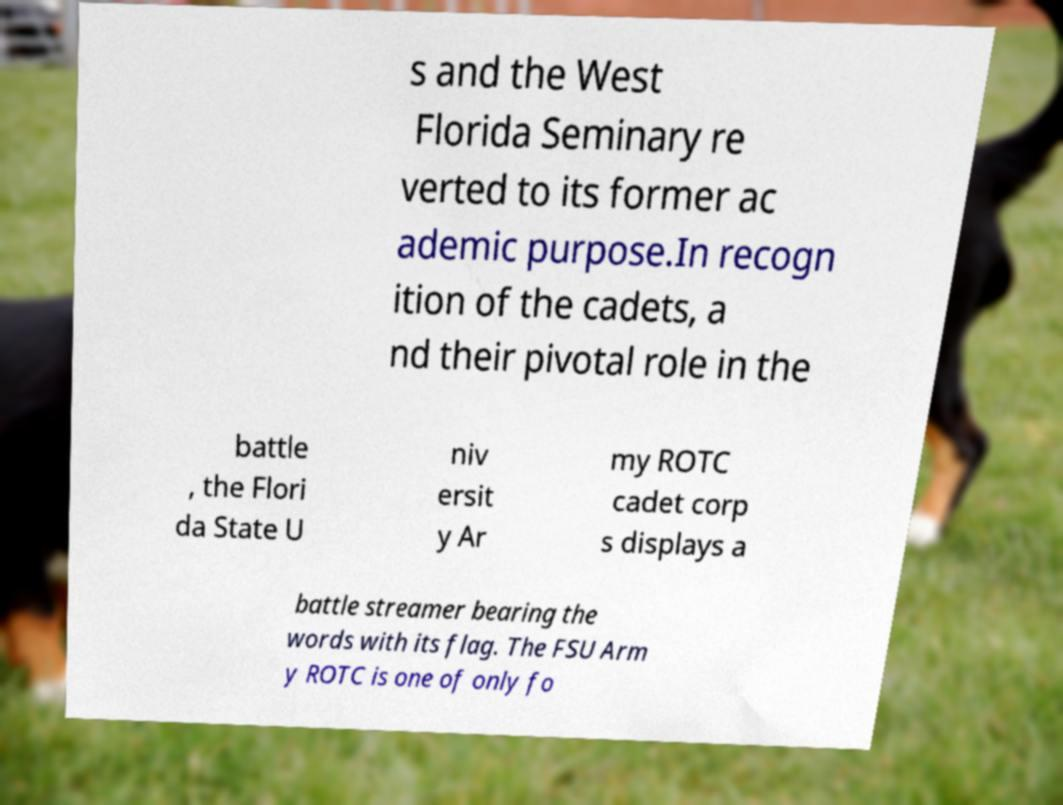Can you accurately transcribe the text from the provided image for me? s and the West Florida Seminary re verted to its former ac ademic purpose.In recogn ition of the cadets, a nd their pivotal role in the battle , the Flori da State U niv ersit y Ar my ROTC cadet corp s displays a battle streamer bearing the words with its flag. The FSU Arm y ROTC is one of only fo 